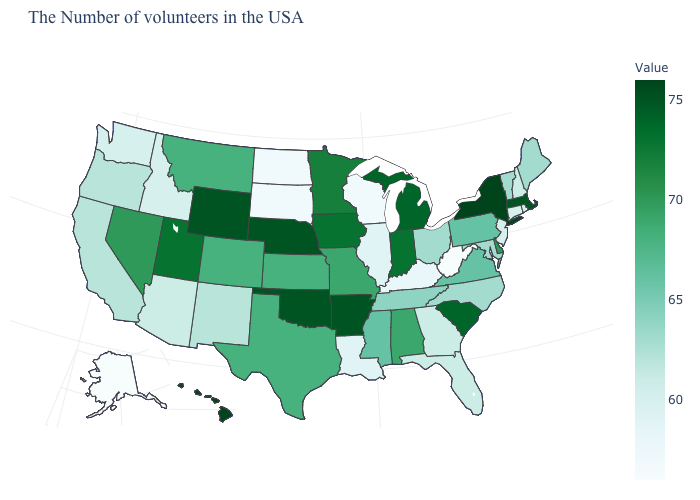Which states have the lowest value in the USA?
Keep it brief. West Virginia, Alaska. Which states have the lowest value in the West?
Answer briefly. Alaska. Among the states that border South Carolina , does Georgia have the highest value?
Concise answer only. No. 